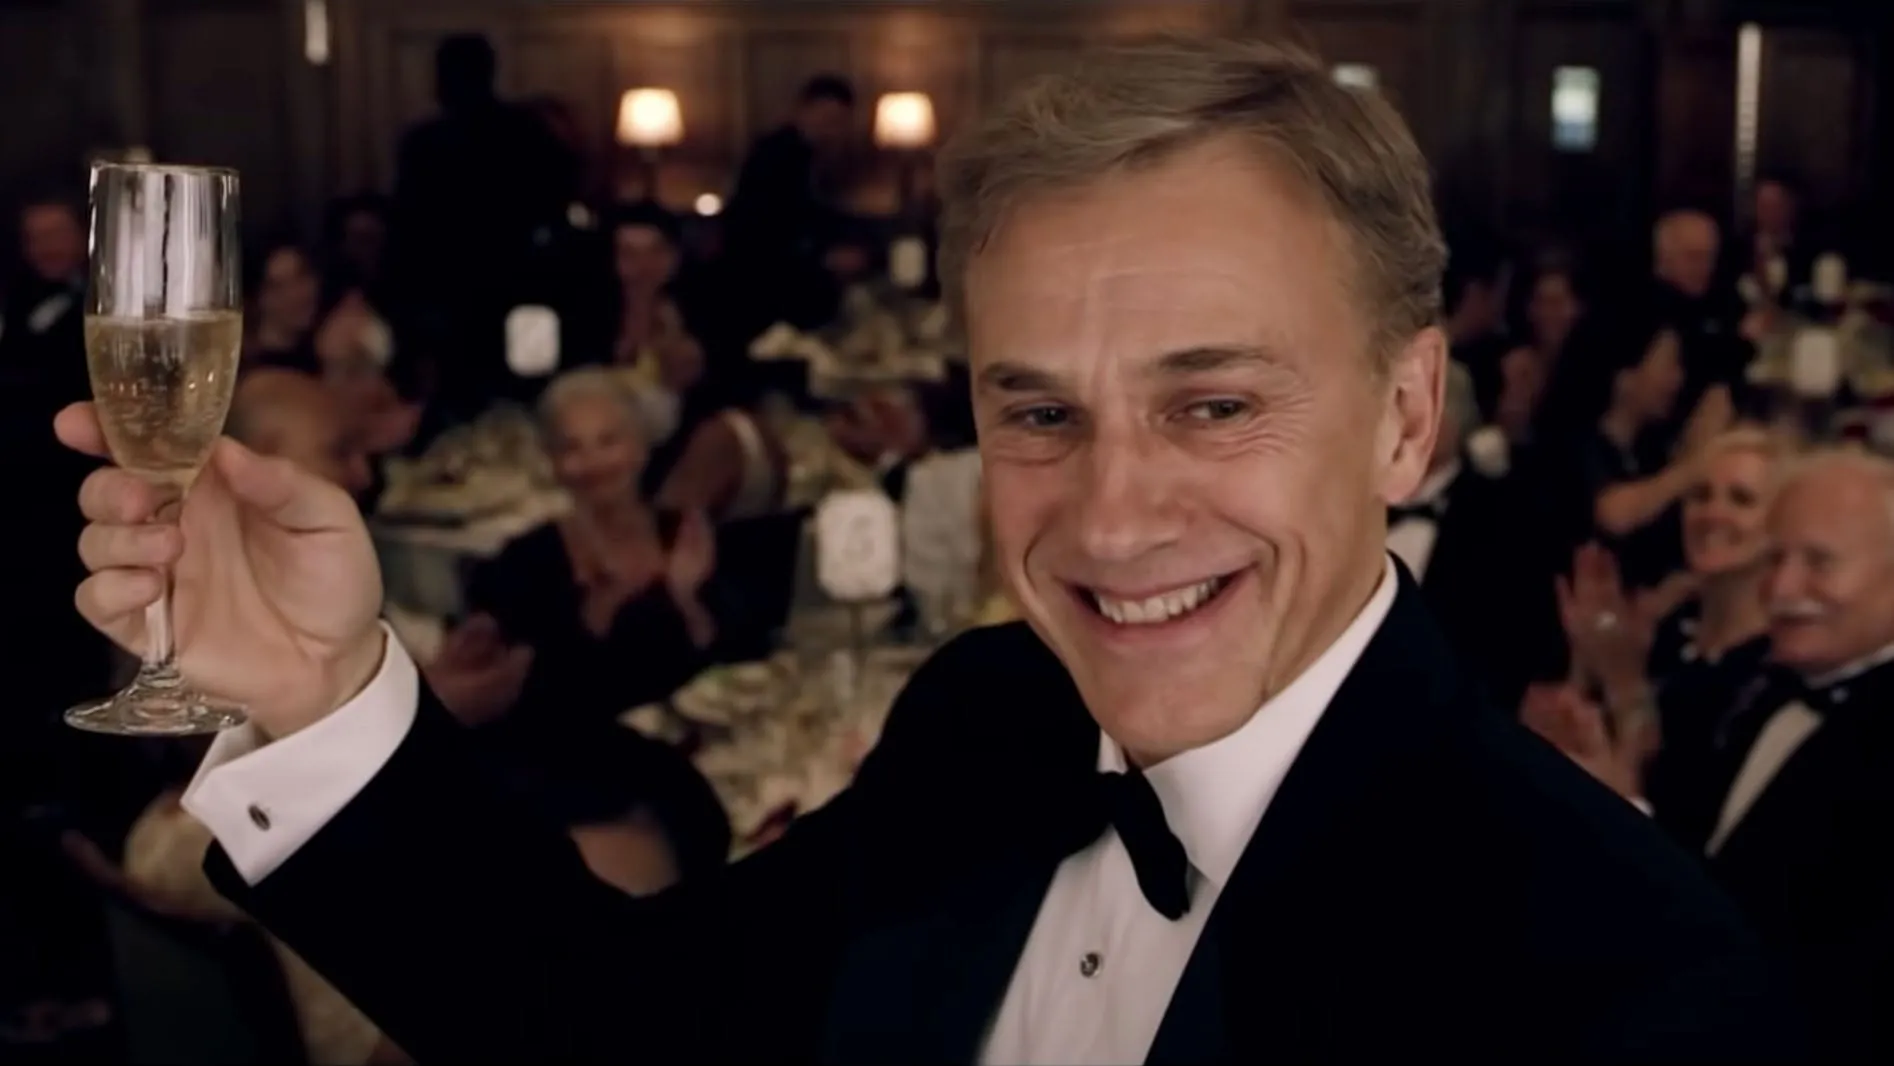Who are some notable people in this picture? There is a prominent gentleman who is the center of attention in this image. He appears to be celebrating with a glass of champagne, indicating a festive atmosphere. The background is filled with other guests who are equally well-dressed, suggesting this is an event attended by notable or important figures, but specific identities beyond the main gentleman are not clear from the image. What's the likely setting for this image? The setting of the image is possibly a luxurious restaurant or a grand ballroom. The formal attire of the guests, the table settings, and the ambient lighting all suggest a high-end event, possibly a gala, award ceremony, or a formal dinner. 